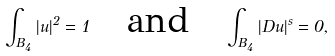Convert formula to latex. <formula><loc_0><loc_0><loc_500><loc_500>\int _ { B _ { 4 } } | u | ^ { 2 } = 1 \quad \text {and} \quad \int _ { B _ { 4 } } | D u | ^ { s } = 0 ,</formula> 